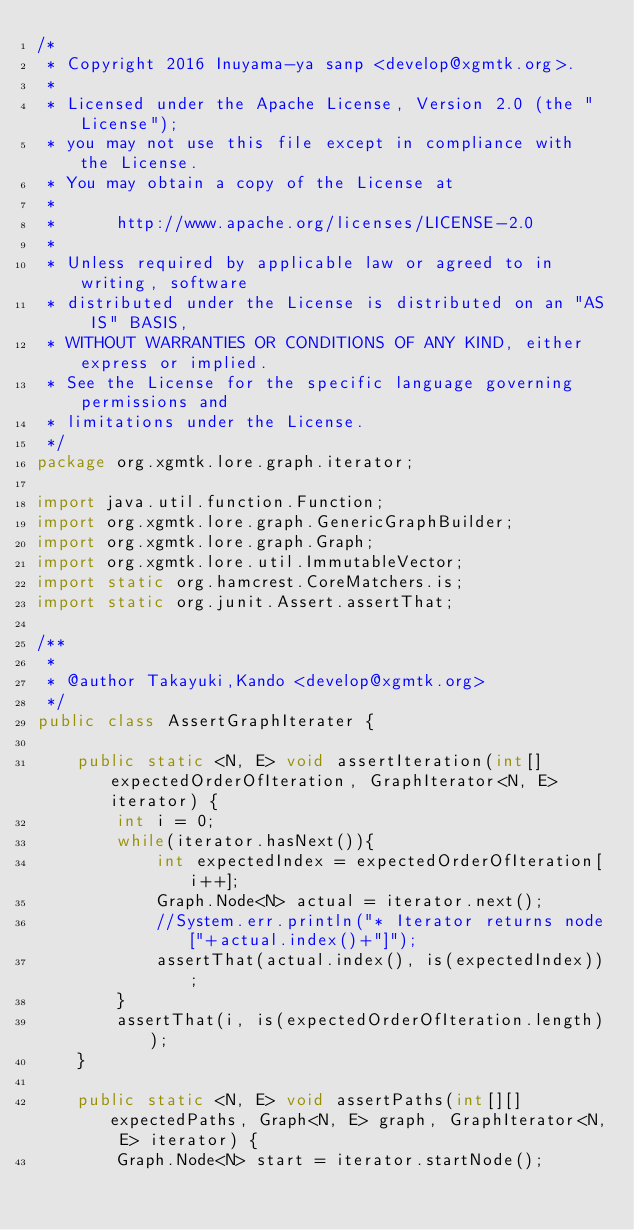Convert code to text. <code><loc_0><loc_0><loc_500><loc_500><_Java_>/*
 * Copyright 2016 Inuyama-ya sanp <develop@xgmtk.org>.
 *
 * Licensed under the Apache License, Version 2.0 (the "License");
 * you may not use this file except in compliance with the License.
 * You may obtain a copy of the License at
 *
 *      http://www.apache.org/licenses/LICENSE-2.0
 *
 * Unless required by applicable law or agreed to in writing, software
 * distributed under the License is distributed on an "AS IS" BASIS,
 * WITHOUT WARRANTIES OR CONDITIONS OF ANY KIND, either express or implied.
 * See the License for the specific language governing permissions and
 * limitations under the License.
 */
package org.xgmtk.lore.graph.iterator;

import java.util.function.Function;
import org.xgmtk.lore.graph.GenericGraphBuilder;
import org.xgmtk.lore.graph.Graph;
import org.xgmtk.lore.util.ImmutableVector;
import static org.hamcrest.CoreMatchers.is;
import static org.junit.Assert.assertThat;

/**
 *
 * @author Takayuki,Kando <develop@xgmtk.org>
 */
public class AssertGraphIterater {
           
    public static <N, E> void assertIteration(int[] expectedOrderOfIteration, GraphIterator<N, E> iterator) {
        int i = 0;
        while(iterator.hasNext()){
            int expectedIndex = expectedOrderOfIteration[i++];
            Graph.Node<N> actual = iterator.next();
            //System.err.println("* Iterator returns node["+actual.index()+"]");
            assertThat(actual.index(), is(expectedIndex));
        }
        assertThat(i, is(expectedOrderOfIteration.length));
    }
    
    public static <N, E> void assertPaths(int[][] expectedPaths, Graph<N, E> graph, GraphIterator<N, E> iterator) {
        Graph.Node<N> start = iterator.startNode();</code> 